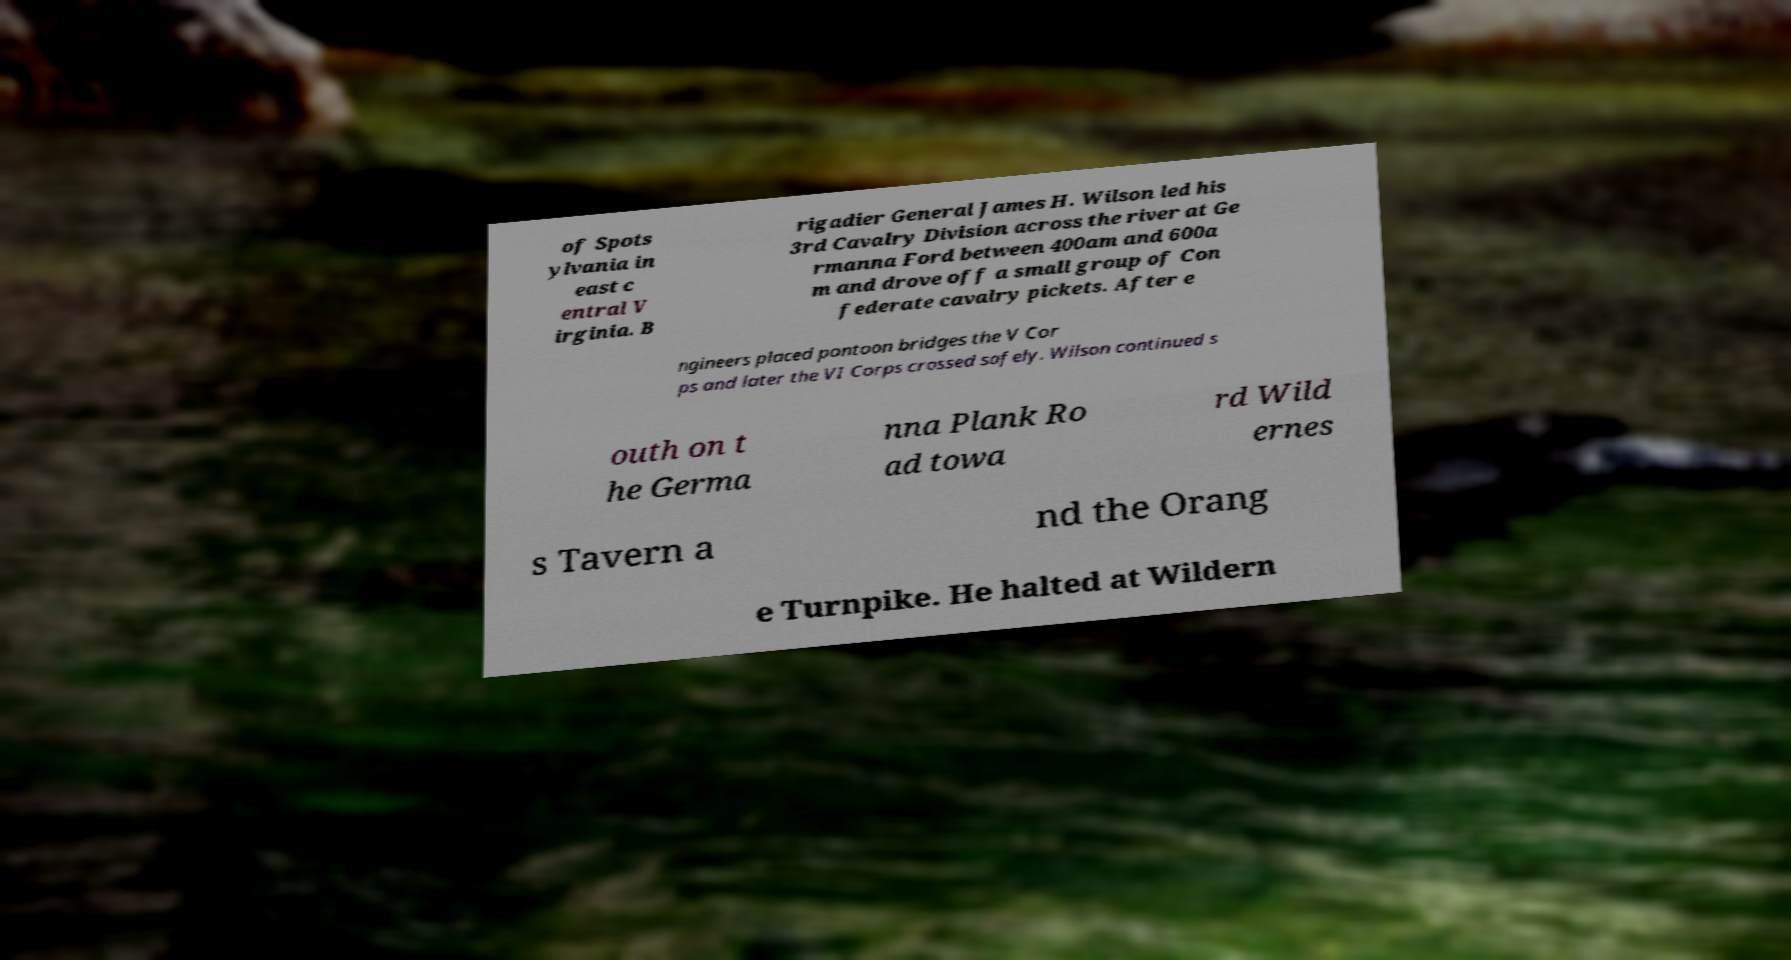I need the written content from this picture converted into text. Can you do that? of Spots ylvania in east c entral V irginia. B rigadier General James H. Wilson led his 3rd Cavalry Division across the river at Ge rmanna Ford between 400am and 600a m and drove off a small group of Con federate cavalry pickets. After e ngineers placed pontoon bridges the V Cor ps and later the VI Corps crossed safely. Wilson continued s outh on t he Germa nna Plank Ro ad towa rd Wild ernes s Tavern a nd the Orang e Turnpike. He halted at Wildern 